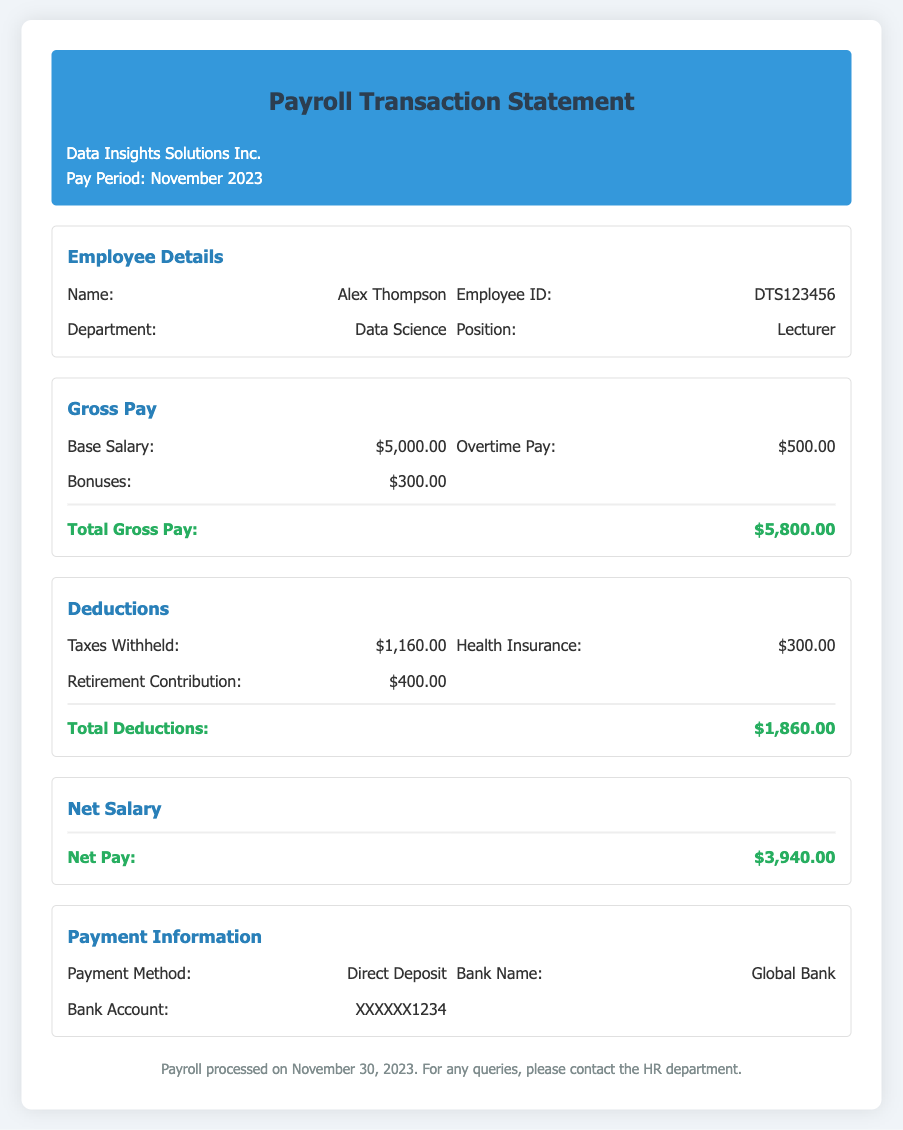What is the employee's name? The employee's name is listed in the Employee Details section of the document, which is Alex Thompson.
Answer: Alex Thompson What is the total gross pay? The total gross pay is provided in the Gross Pay section, calculated as the sum of base salary, overtime pay, and bonuses, which amounts to $5,800.00.
Answer: $5,800.00 How much is withheld for taxes? The amount withheld for taxes is specified in the Deductions section as $1,160.00.
Answer: $1,160.00 What is the net pay for November 2023? The net pay is summarised in the Net Salary section and is calculated as total gross pay minus total deductions, resulting in $3,940.00.
Answer: $3,940.00 What payment method is used? The payment method is indicated in the Payment Information section as Direct Deposit.
Answer: Direct Deposit How much is contributed to retirement? The deduction for retirement contribution is mentioned under Deductions, stated as $400.00.
Answer: $400.00 What is the name of the bank? The bank name is provided in the Payment Information section and is Global Bank.
Answer: Global Bank When was the payroll processed? The document states that the payroll was processed on November 30, 2023.
Answer: November 30, 2023 Which department does the employee belong to? The employee's department is mentioned in the Employee Details section as Data Science.
Answer: Data Science 